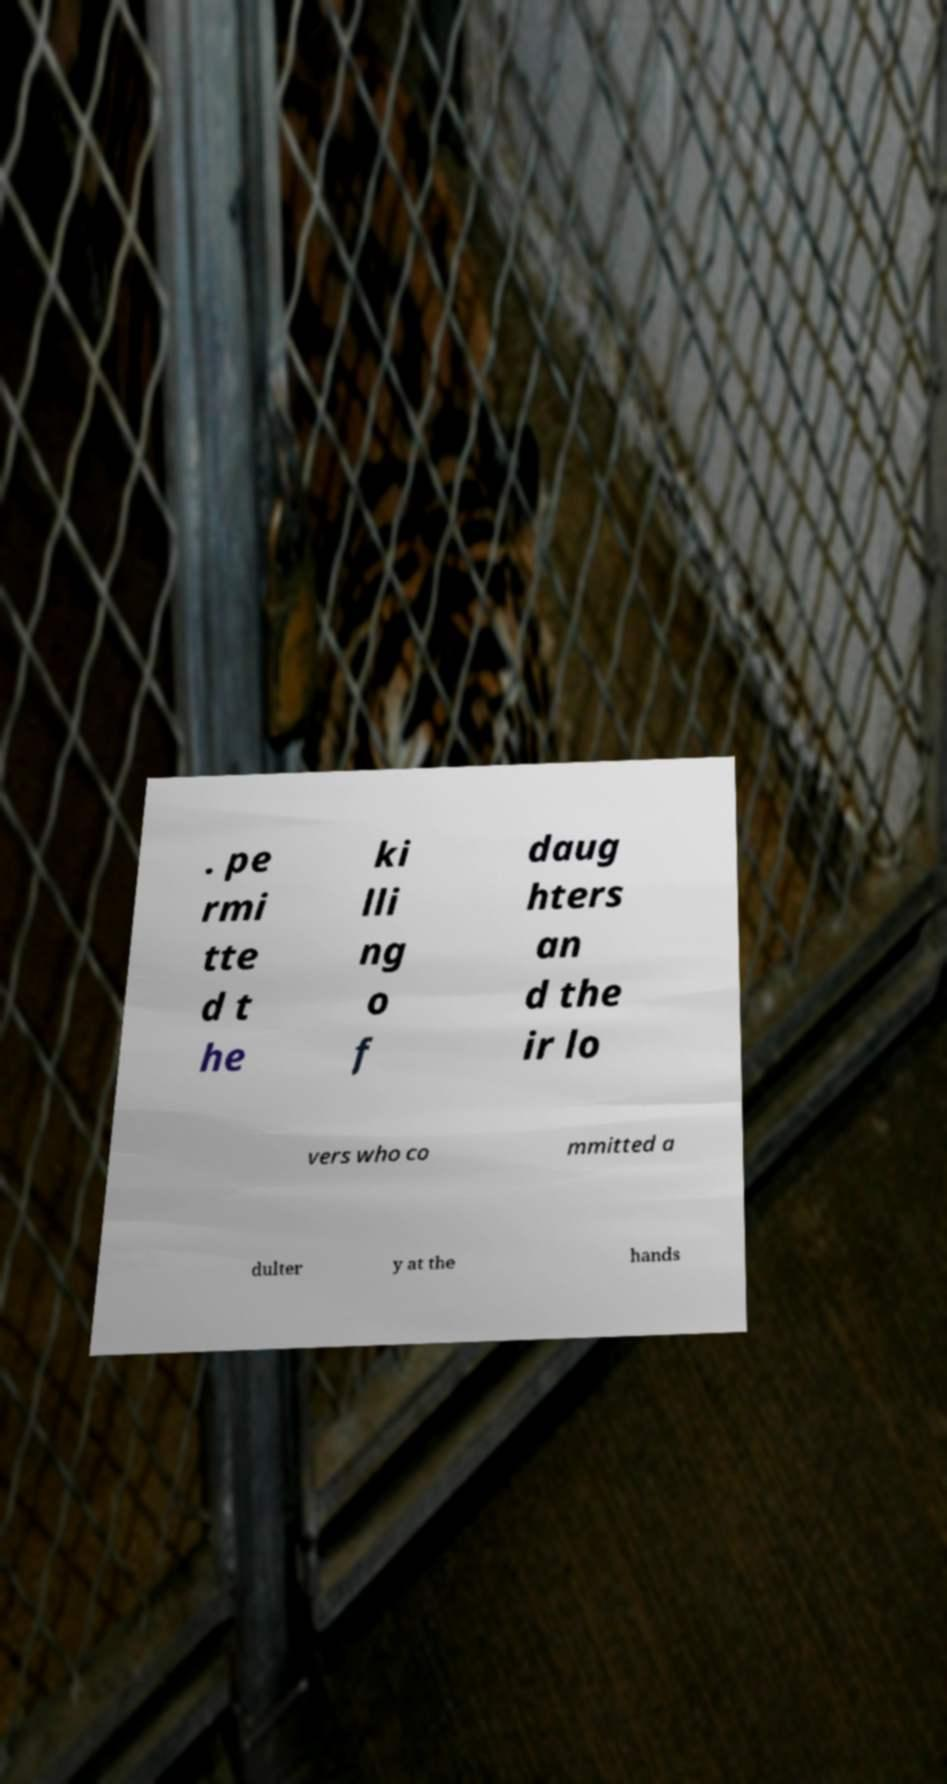There's text embedded in this image that I need extracted. Can you transcribe it verbatim? . pe rmi tte d t he ki lli ng o f daug hters an d the ir lo vers who co mmitted a dulter y at the hands 